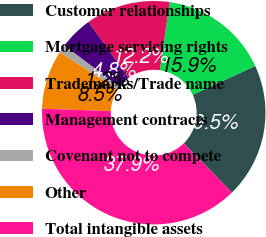Convert chart. <chart><loc_0><loc_0><loc_500><loc_500><pie_chart><fcel>Customer relationships<fcel>Mortgage servicing rights<fcel>Trademarks/Trade name<fcel>Management contracts<fcel>Covenant not to compete<fcel>Other<fcel>Total intangible assets<nl><fcel>19.53%<fcel>15.86%<fcel>12.19%<fcel>4.84%<fcel>1.16%<fcel>8.51%<fcel>37.9%<nl></chart> 